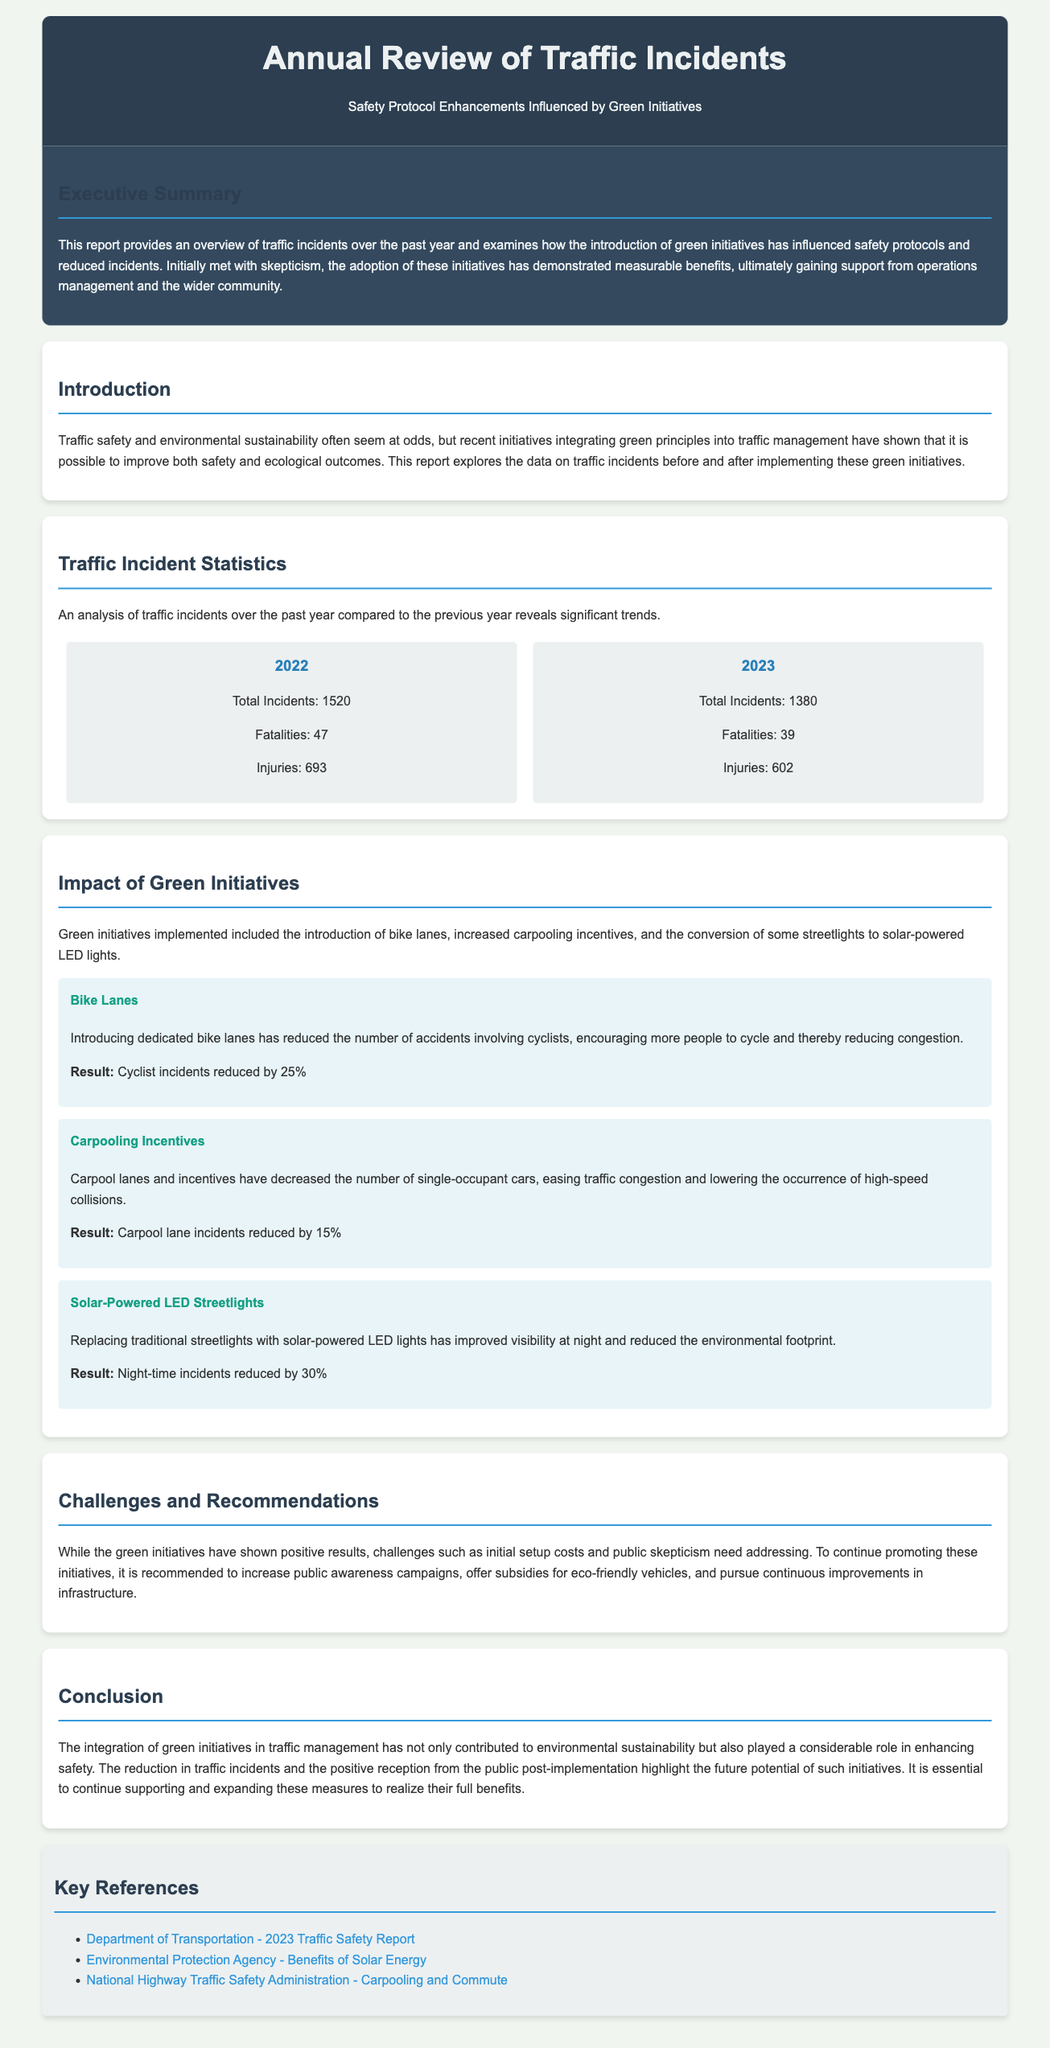What was the total number of traffic incidents in 2022? The document states that the total incidents in 2022 were 1520.
Answer: 1520 What percentage did cyclist incidents reduce by after implementing bike lanes? The reduction mentioned in the document for cyclist incidents is 25%.
Answer: 25% How many fatalities were reported in 2023? The document indicates that there were 39 fatalities reported in 2023.
Answer: 39 What initiative is associated with reducing night-time incidents by 30%? The initiative described in the document related to night-time incidents is the installation of solar-powered LED streetlights.
Answer: Solar-Powered LED Streetlights Which year saw a reduction in total incidents compared to the previous year? The document shows that total incidents decreased from 1520 in 2022 to 1380 in 2023.
Answer: 2023 What is one of the recommended strategies to promote green initiatives further? The document suggests increasing public awareness campaigns as one of the strategies.
Answer: Increase public awareness campaigns How many injuries were reported in 2022? According to the document, the total injuries reported in 2022 were 693.
Answer: 693 What is the focus of the executive summary? The executive summary discusses the overview of traffic incidents and the influence of green initiatives on safety protocols.
Answer: Overview of traffic incidents and influence of green initiatives 